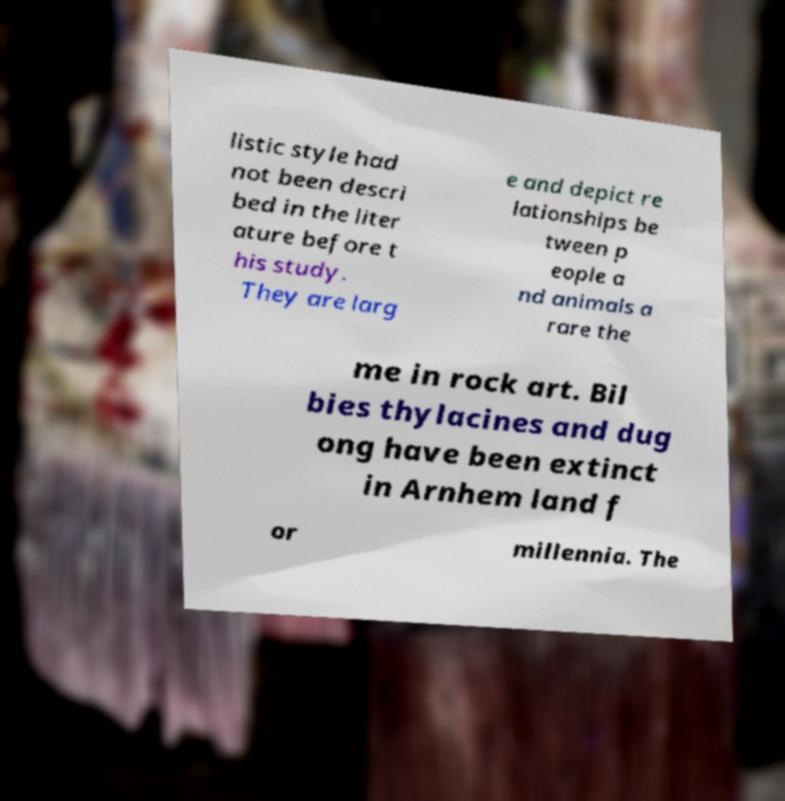Can you read and provide the text displayed in the image?This photo seems to have some interesting text. Can you extract and type it out for me? listic style had not been descri bed in the liter ature before t his study. They are larg e and depict re lationships be tween p eople a nd animals a rare the me in rock art. Bil bies thylacines and dug ong have been extinct in Arnhem land f or millennia. The 